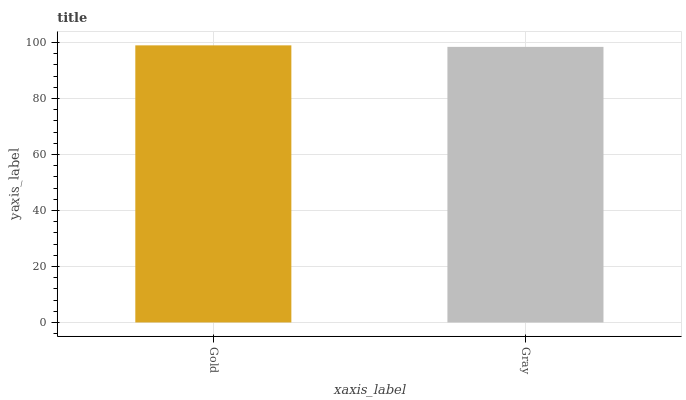Is Gray the minimum?
Answer yes or no. Yes. Is Gold the maximum?
Answer yes or no. Yes. Is Gray the maximum?
Answer yes or no. No. Is Gold greater than Gray?
Answer yes or no. Yes. Is Gray less than Gold?
Answer yes or no. Yes. Is Gray greater than Gold?
Answer yes or no. No. Is Gold less than Gray?
Answer yes or no. No. Is Gold the high median?
Answer yes or no. Yes. Is Gray the low median?
Answer yes or no. Yes. Is Gray the high median?
Answer yes or no. No. Is Gold the low median?
Answer yes or no. No. 